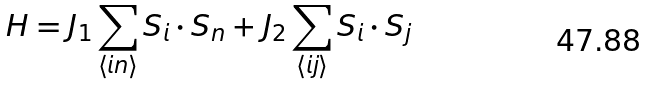<formula> <loc_0><loc_0><loc_500><loc_500>H = J _ { 1 } \sum _ { \langle i n \rangle } { S } _ { i } \cdot { S } _ { n } + J _ { 2 } \sum _ { \langle i j \rangle } { S } _ { i } \cdot { S } _ { j }</formula> 